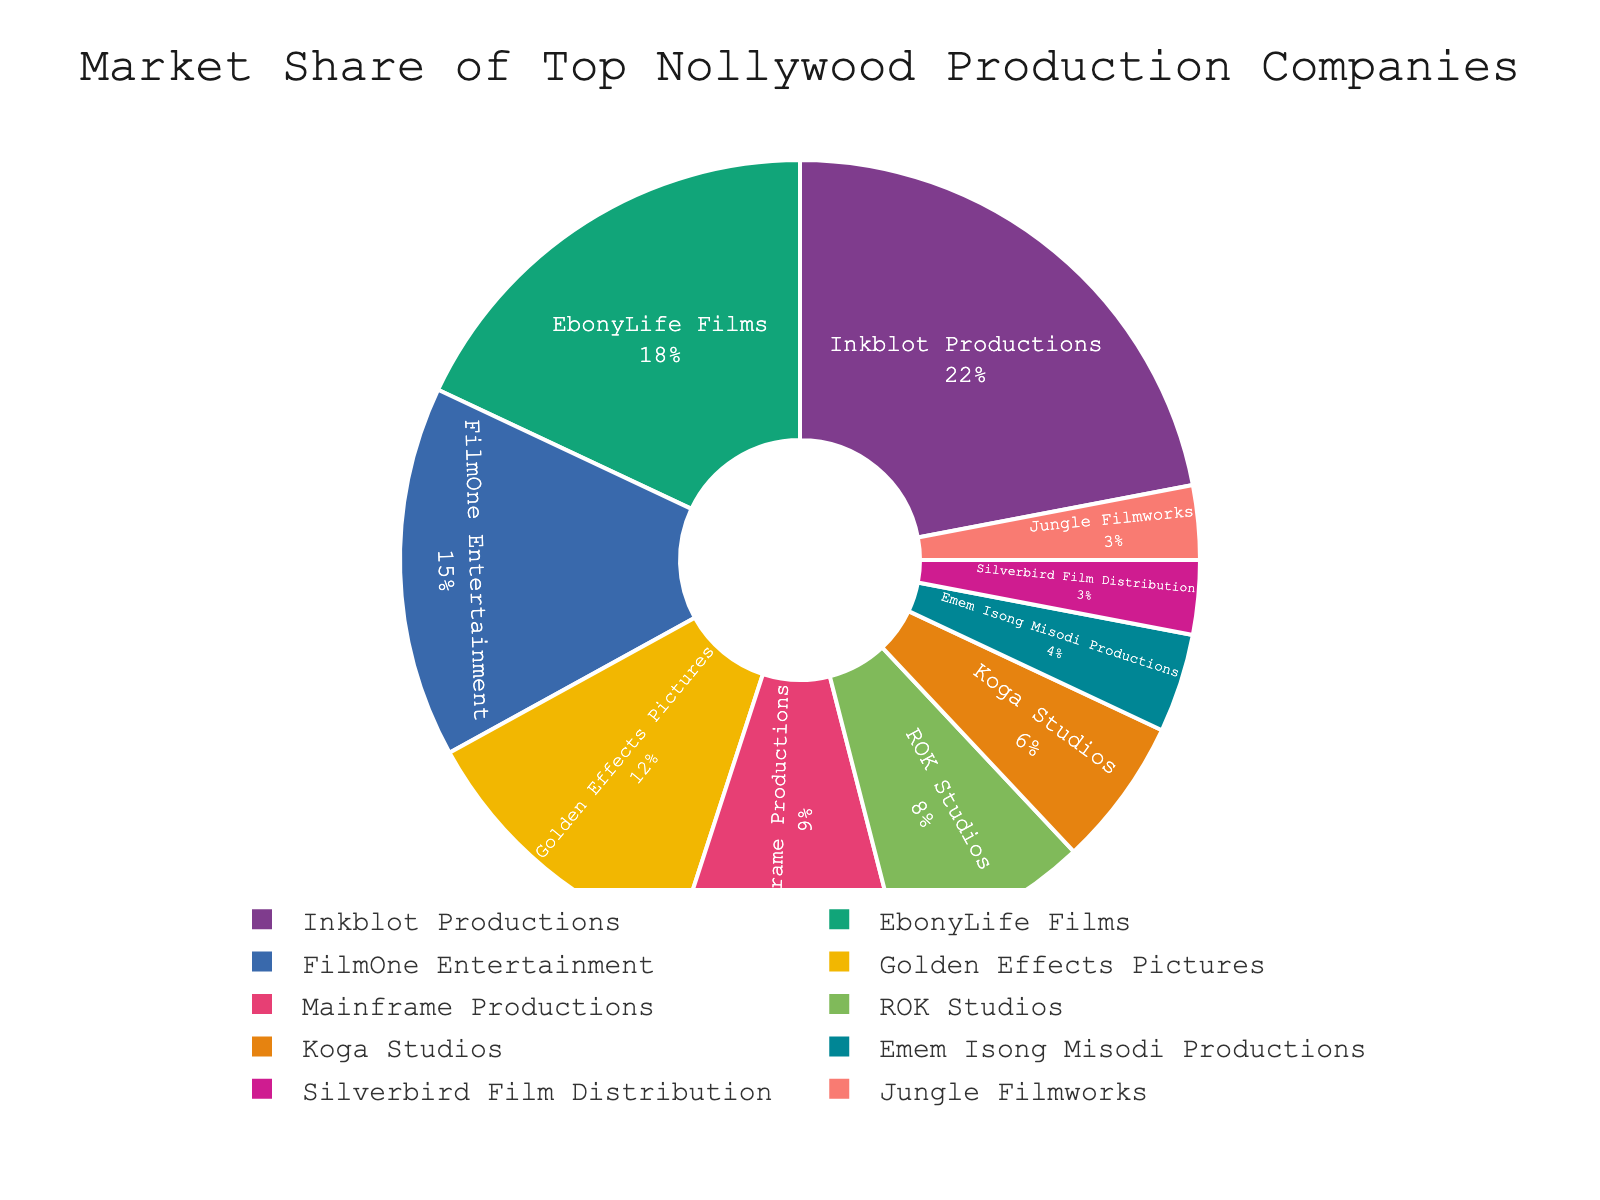What is the market share of Inkblot Productions? The pie chart visually displays the market share of each production company. Inkblot Productions has the largest segment.
Answer: 22% Which company has the third largest market share? By examining the size of the slices, the third largest is identified as FilmOne Entertainment.
Answer: FilmOne Entertainment What is the combined market share of Golden Effects Pictures and Mainframe Productions? Golden Effects Pictures has a 12% share, and Mainframe Productions has 9%. Adding these up: 12% + 9% = 21%.
Answer: 21% How does the market share of EbonyLife Films compare to that of ROK Studios? EbonyLife Films has an 18% market share, and ROK Studios has an 8% market share. 18% is greater than 8%.
Answer: EbonyLife Films has a larger market share than ROK Studios What is the total market share of the companies with less than 5% each? Emem Isong Misodi Productions, Silverbird Film Distribution, and Jungle Filmworks each have less than 5%. Their shares sum up: 4% + 3% + 3% = 10%.
Answer: 10% Which color represents EbonyLife Films, and what is its market share? Identify the color associated with the slice marked EbonyLife Films, which shows 18%.
Answer: EbonyLife Films is represented by the (color) and has an 18% market share When comparing FilmOne Entertainment to Mainframe Productions, how much larger is FilmOne Entertainment’s market share? FilmOne Entertainment has 15%, while Mainframe Productions has 9%. The difference is 15% - 9% = 6%.
Answer: 6% What percentage of the market does the top three companies collectively hold? The top three are Inkblot Productions (22%), EbonyLife Films (18%), and FilmOne Entertainment (15%). Total: 22% + 18% + 15% = 55%.
Answer: 55% Which company ranks just below Golden Effects Pictures in market share? The next largest slice after Golden Effects Pictures (12%) belongs to Mainframe Productions (9%).
Answer: Mainframe Productions How much larger is the market share of the largest company compared to the smallest company? The largest company is Inkblot Productions with 22%, and the smallest companies (Silverbird Film Distribution, Jungle Filmworks) each have 3%. Difference: 22% - 3% = 19%.
Answer: 19% 